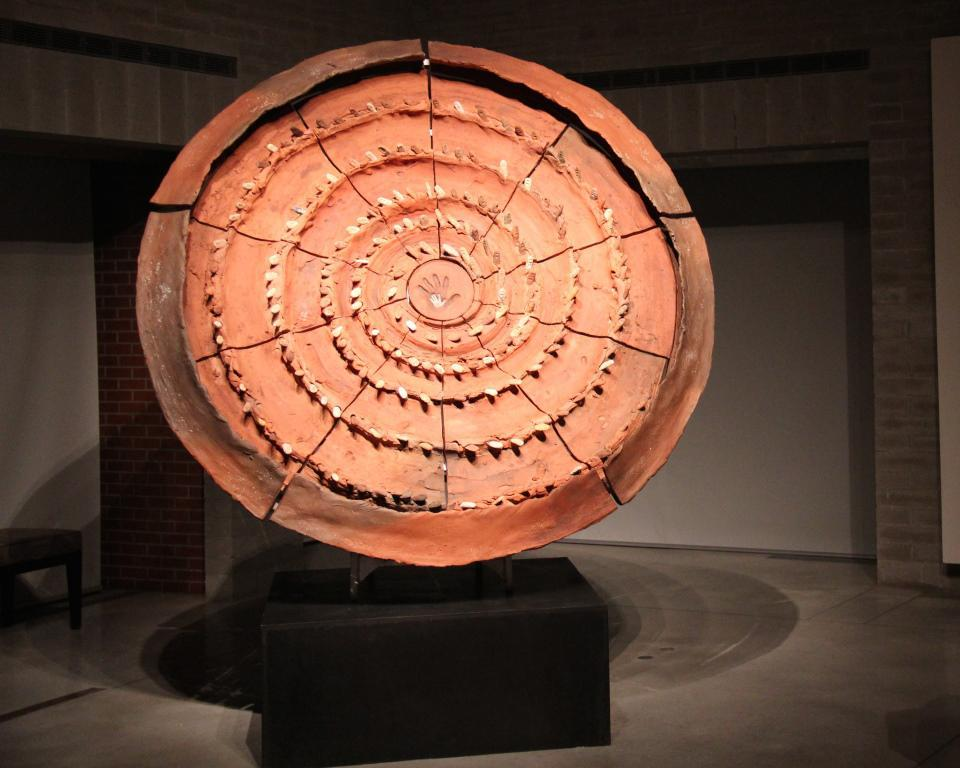What is placed on the ground in the image? There is an artifact placed on the ground. Can you describe the background of the image? There is a chair in the background of the image. What type of ring is the artifact wearing in the image? There is no ring present in the image, as the artifact is not a person or entity capable of wearing a ring. 